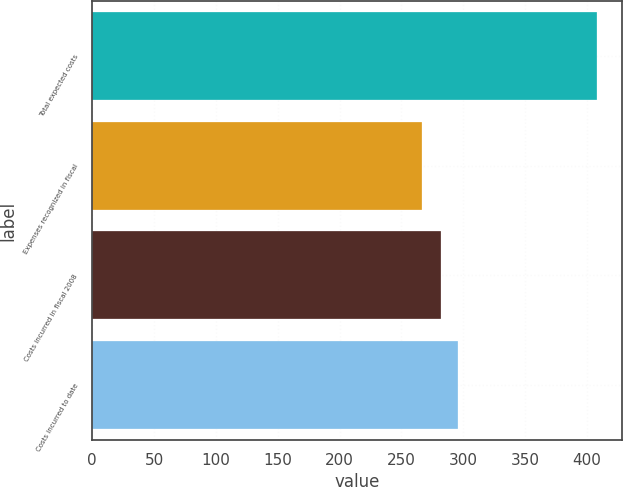Convert chart. <chart><loc_0><loc_0><loc_500><loc_500><bar_chart><fcel>Total expected costs<fcel>Expenses recognized in fiscal<fcel>Costs incurred in fiscal 2008<fcel>Costs incurred to date<nl><fcel>407.8<fcel>266.9<fcel>281.7<fcel>295.79<nl></chart> 